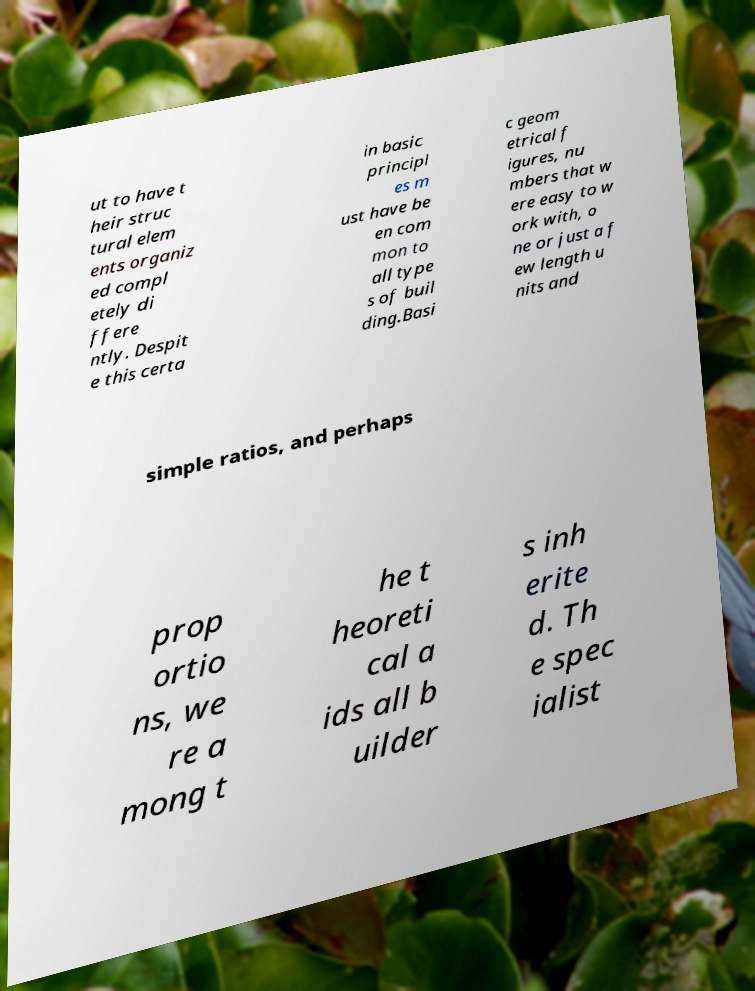For documentation purposes, I need the text within this image transcribed. Could you provide that? ut to have t heir struc tural elem ents organiz ed compl etely di ffere ntly. Despit e this certa in basic principl es m ust have be en com mon to all type s of buil ding.Basi c geom etrical f igures, nu mbers that w ere easy to w ork with, o ne or just a f ew length u nits and simple ratios, and perhaps prop ortio ns, we re a mong t he t heoreti cal a ids all b uilder s inh erite d. Th e spec ialist 